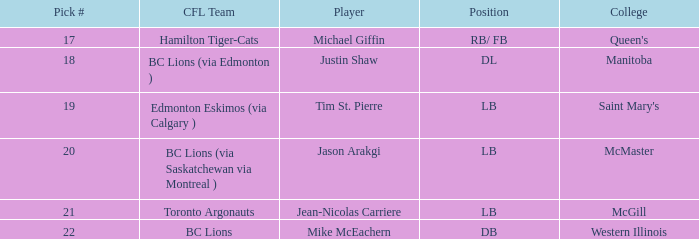What draft position did western illinois hold? 22.0. 